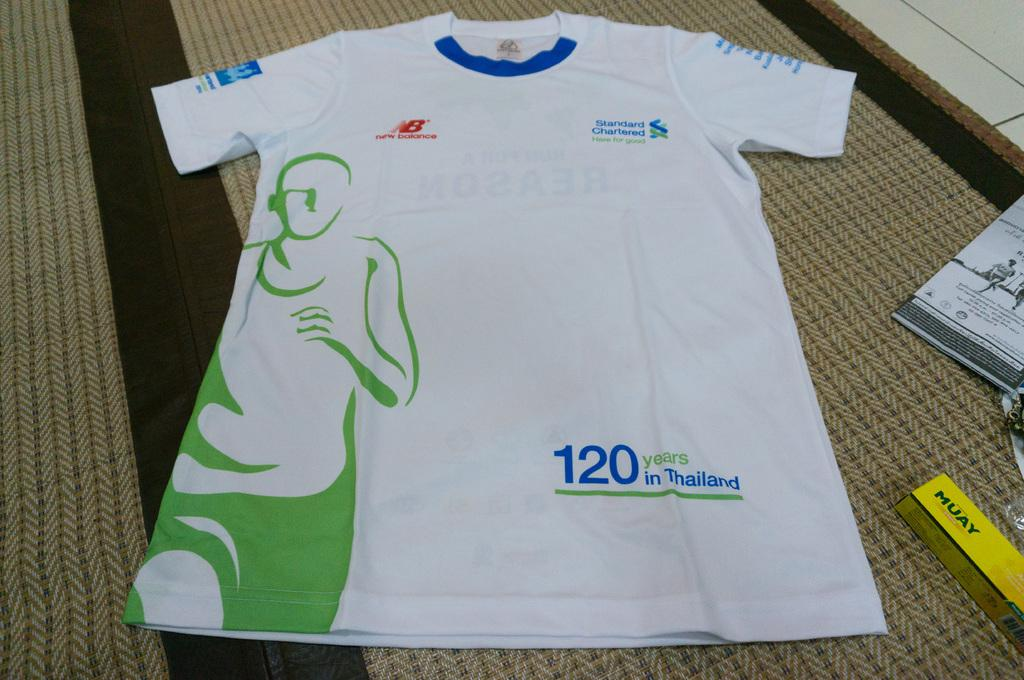Provide a one-sentence caption for the provided image. A shirt that says 120 years in Thailand. 